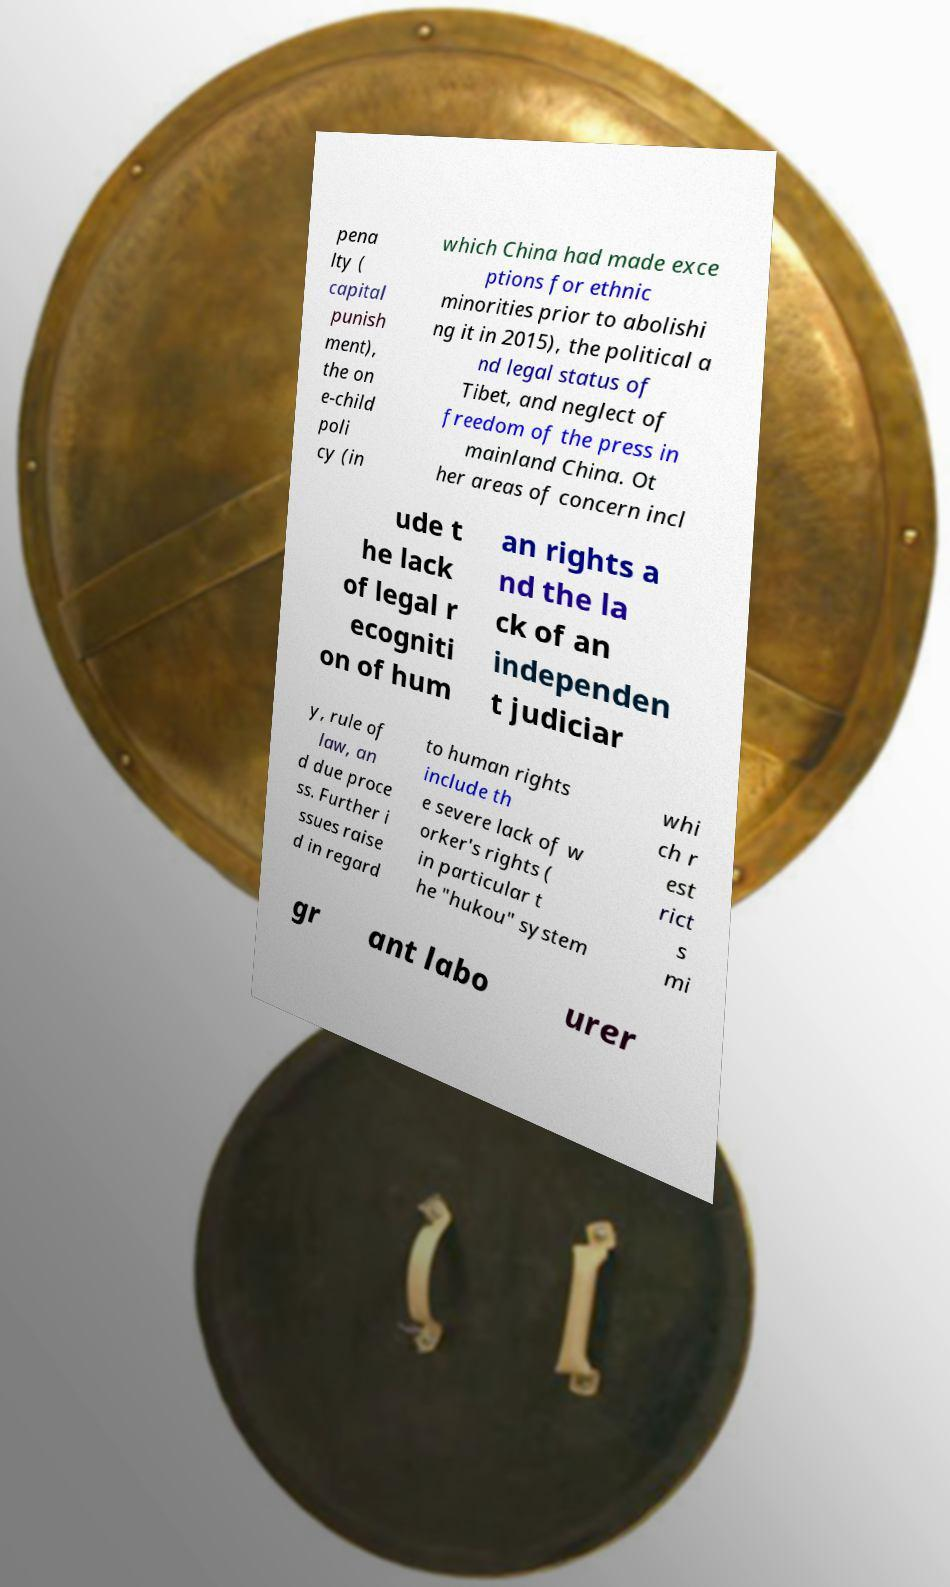Could you extract and type out the text from this image? pena lty ( capital punish ment), the on e-child poli cy (in which China had made exce ptions for ethnic minorities prior to abolishi ng it in 2015), the political a nd legal status of Tibet, and neglect of freedom of the press in mainland China. Ot her areas of concern incl ude t he lack of legal r ecogniti on of hum an rights a nd the la ck of an independen t judiciar y, rule of law, an d due proce ss. Further i ssues raise d in regard to human rights include th e severe lack of w orker's rights ( in particular t he "hukou" system whi ch r est rict s mi gr ant labo urer 